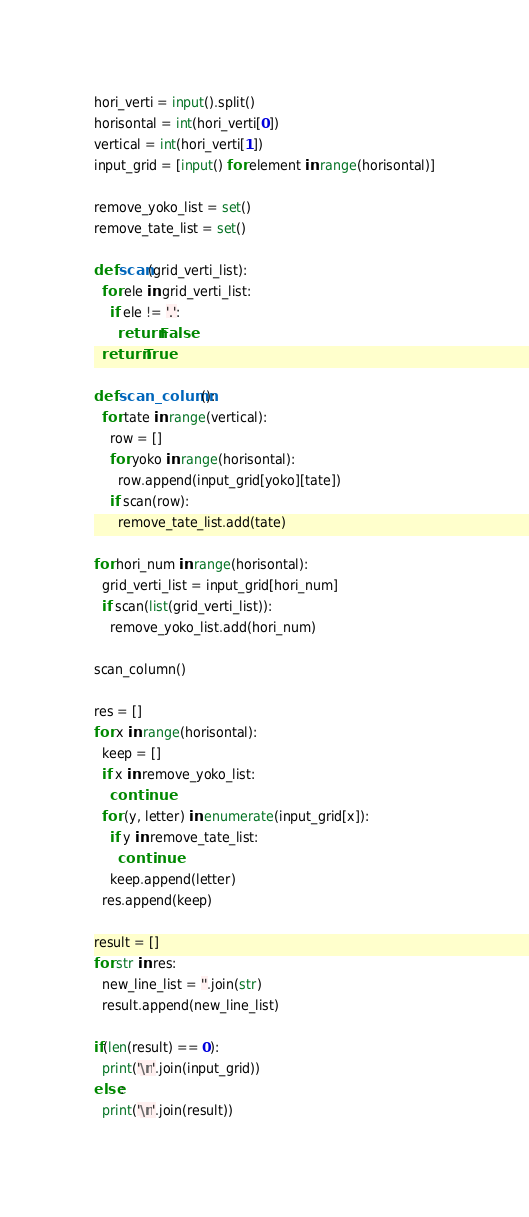Convert code to text. <code><loc_0><loc_0><loc_500><loc_500><_Python_>hori_verti = input().split()
horisontal = int(hori_verti[0])
vertical = int(hori_verti[1])
input_grid = [input() for element in range(horisontal)]

remove_yoko_list = set()
remove_tate_list = set()

def scan(grid_verti_list):
  for ele in grid_verti_list:
    if ele != '.':
      return False
  return True

def scan_column():
  for tate in range(vertical):
    row = []
    for yoko in range(horisontal):
      row.append(input_grid[yoko][tate])
    if scan(row):
      remove_tate_list.add(tate)      

for hori_num in range(horisontal):
  grid_verti_list = input_grid[hori_num]
  if scan(list(grid_verti_list)):
    remove_yoko_list.add(hori_num)
    
scan_column()

res = []
for x in range(horisontal):
  keep = []
  if x in remove_yoko_list:
    continue
  for (y, letter) in enumerate(input_grid[x]):
    if y in remove_tate_list:
      continue
    keep.append(letter)
  res.append(keep)
      
result = []  
for str in res:
  new_line_list = ''.join(str)
  result.append(new_line_list)

if(len(result) == 0):
  print('\n'.join(input_grid))
else:
  print('\n'.join(result))</code> 